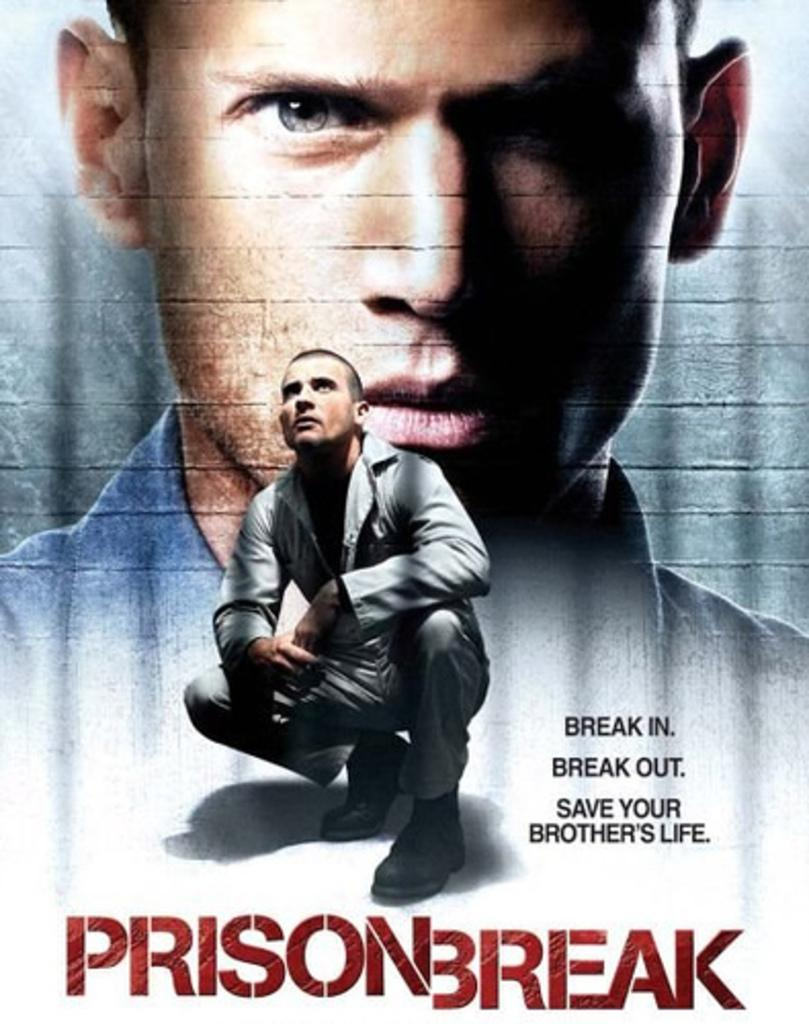What is present in the image that features a visual representation? There is a poster in the image. What can be seen on the poster? The poster contains two persons. Are there any words or phrases on the poster? Yes, there is text written on the poster. How many fish can be seen swimming in the poster? There are no fish present in the image or on the poster. 